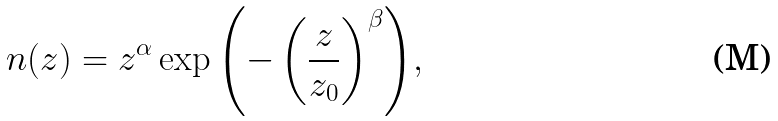<formula> <loc_0><loc_0><loc_500><loc_500>n ( z ) = z ^ { \alpha } \exp { \left ( - \left ( \frac { z } { z _ { 0 } } \right ) ^ { \beta } \right ) } ,</formula> 